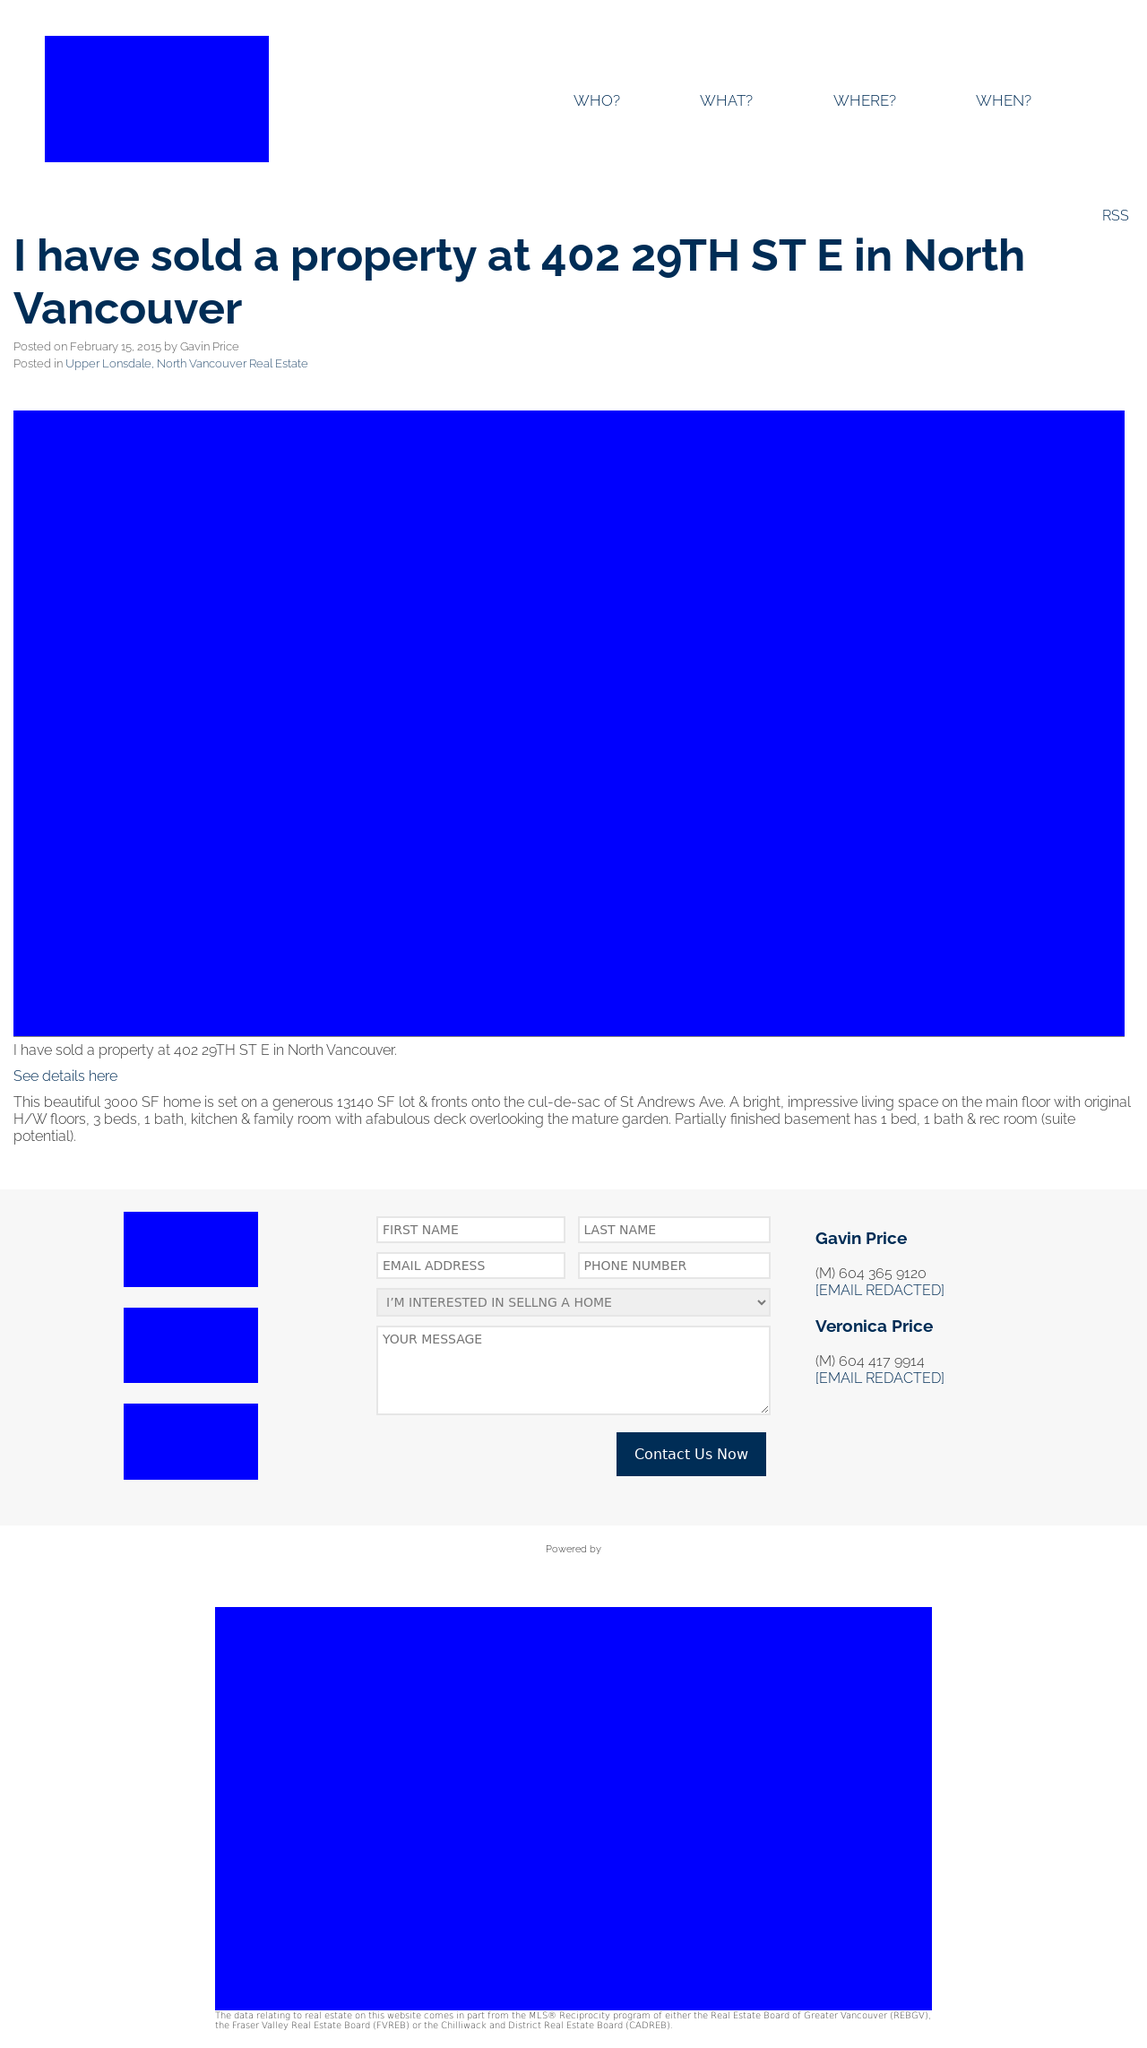Can you describe the primary colors used in this web design? The primary color used in this web design is a vibrant shade of blue, which dominates the background of the header, footers, and several major content blocks. This bold color choice sets a dynamic and modern tone for the website.  What feelings or messages might the use of such a bold blue convey to the visitors of this website? The use of a bold blue is often associated with trustworthiness, reliability, and confidence. For a website like this, which deals with real estate, such colors help in establishing a sense of reliability and professionalism. It could make visitors feel more secure in their interactions and decisions related to property transactions presented on the site. 